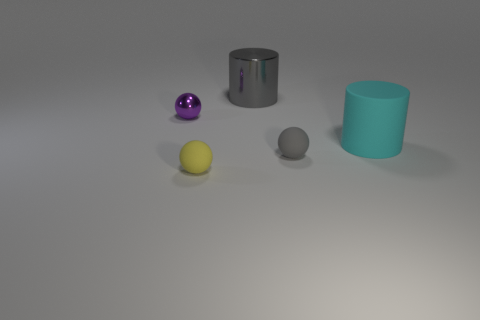Subtract all small rubber spheres. How many spheres are left? 1 Add 3 tiny red shiny cylinders. How many objects exist? 8 Add 2 large cyan matte objects. How many large cyan matte objects exist? 3 Subtract 0 blue cylinders. How many objects are left? 5 Subtract all balls. How many objects are left? 2 Subtract all cyan balls. Subtract all red blocks. How many balls are left? 3 Subtract all gray things. Subtract all yellow blocks. How many objects are left? 3 Add 1 purple balls. How many purple balls are left? 2 